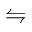<formula> <loc_0><loc_0><loc_500><loc_500>\leftrightharpoons</formula> 